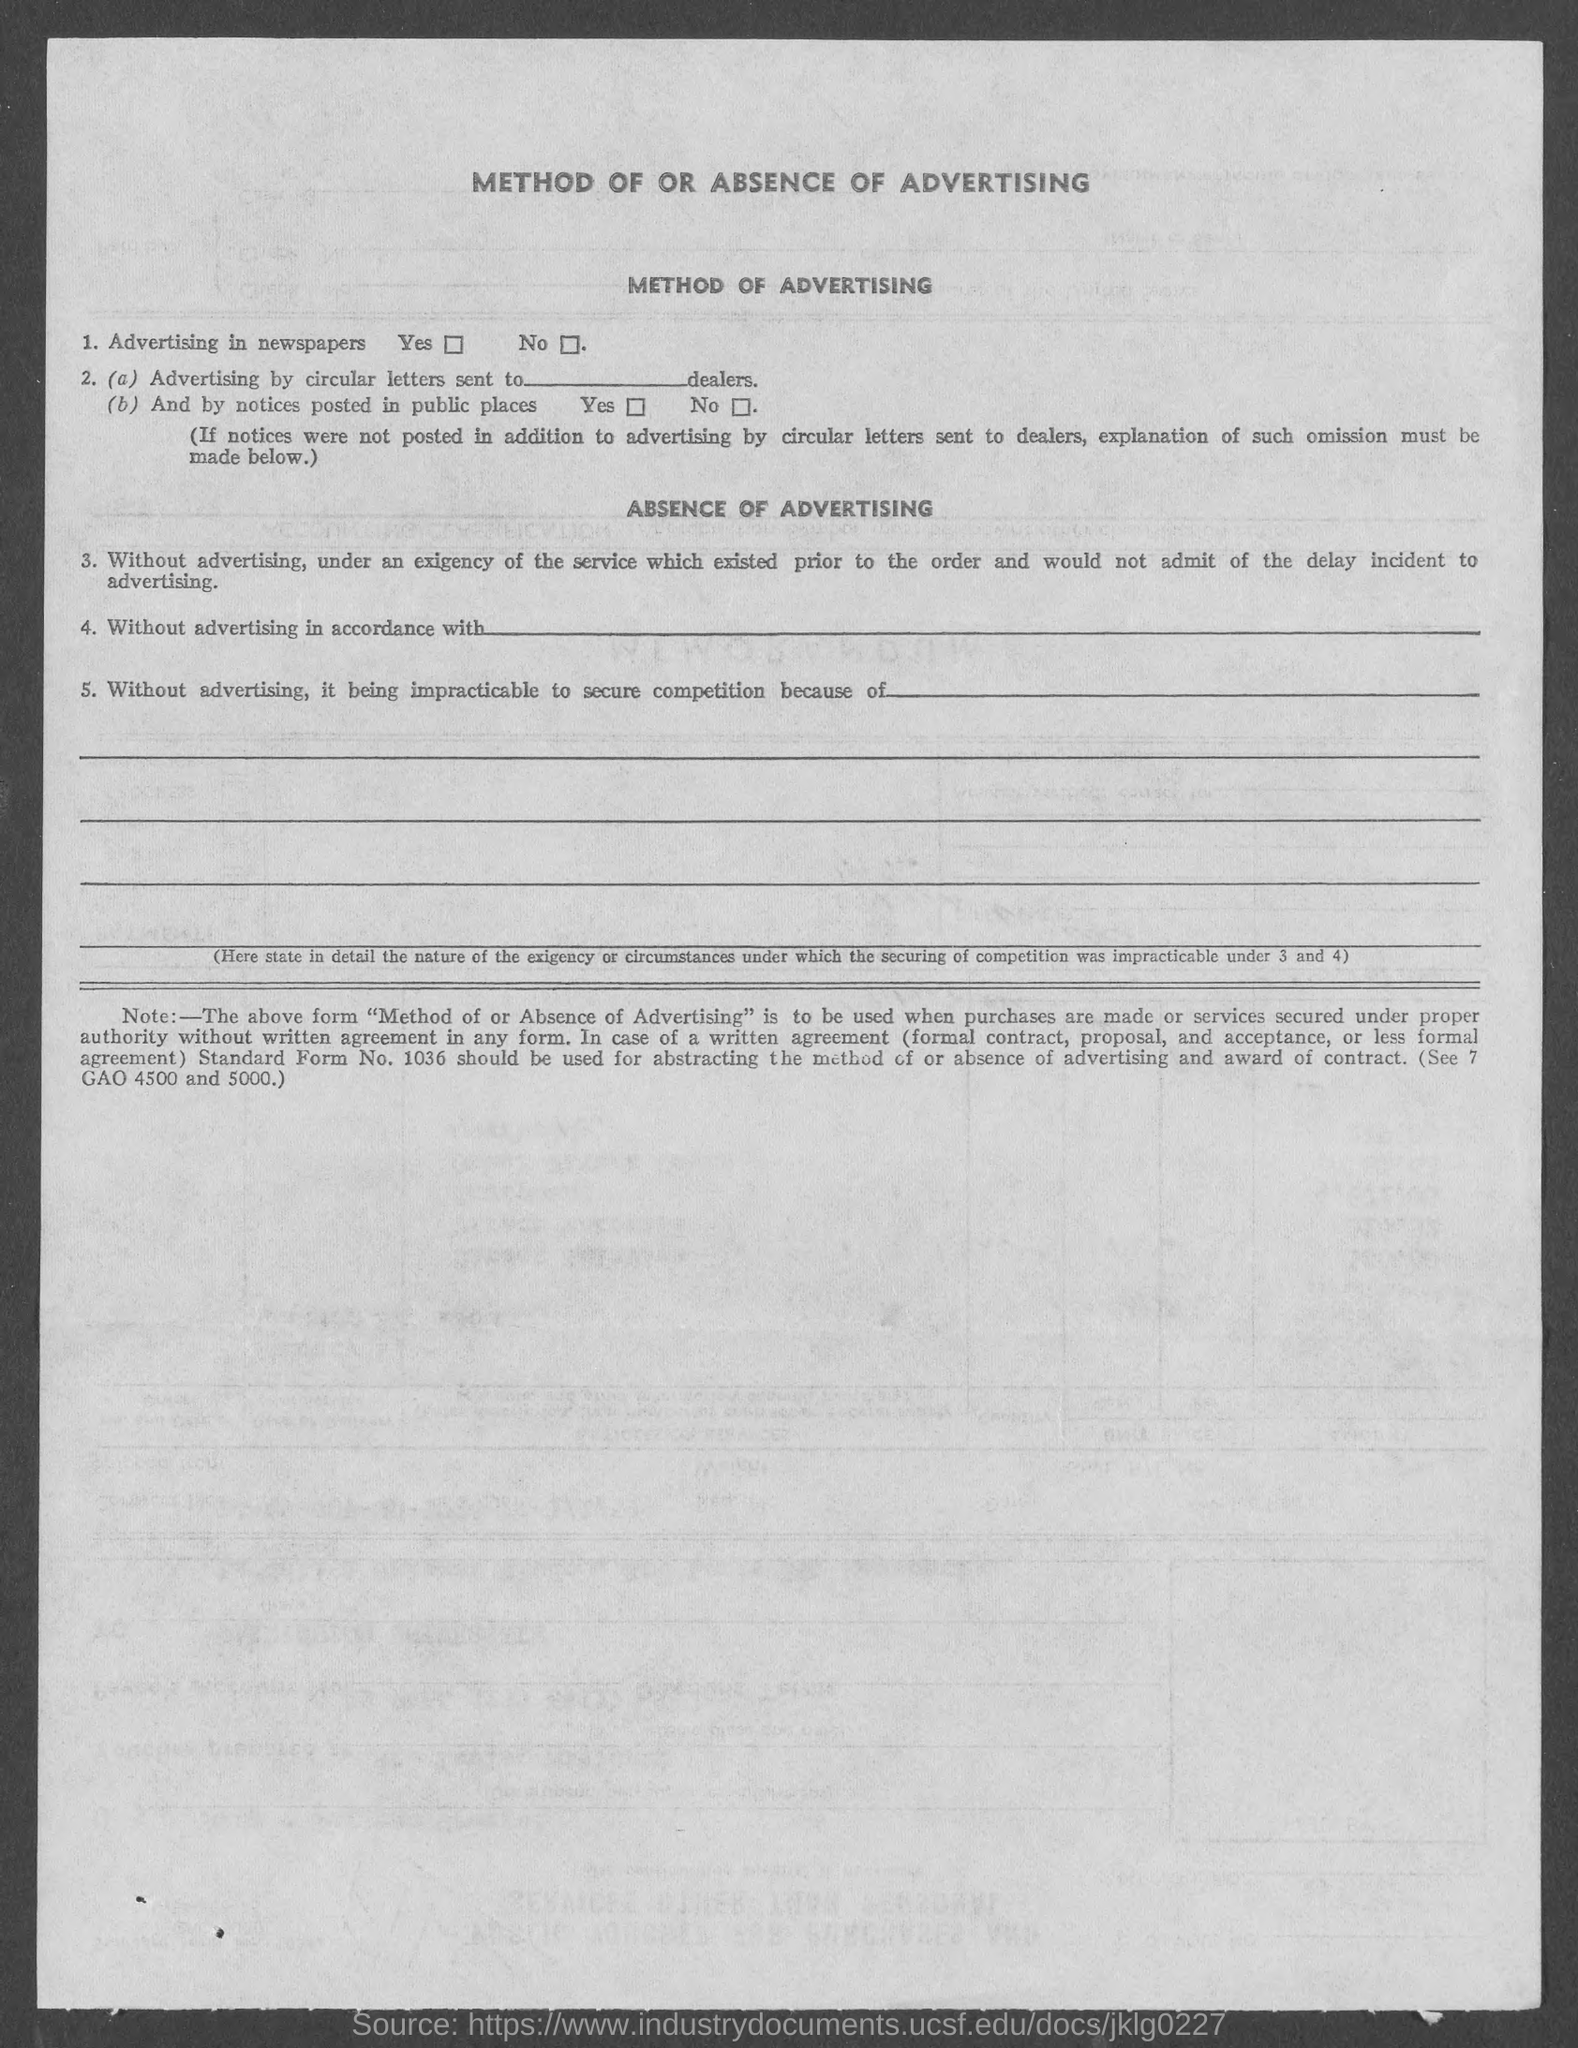What is heading at top of the page ?
Ensure brevity in your answer.  Method of or Absence of Advertising. 